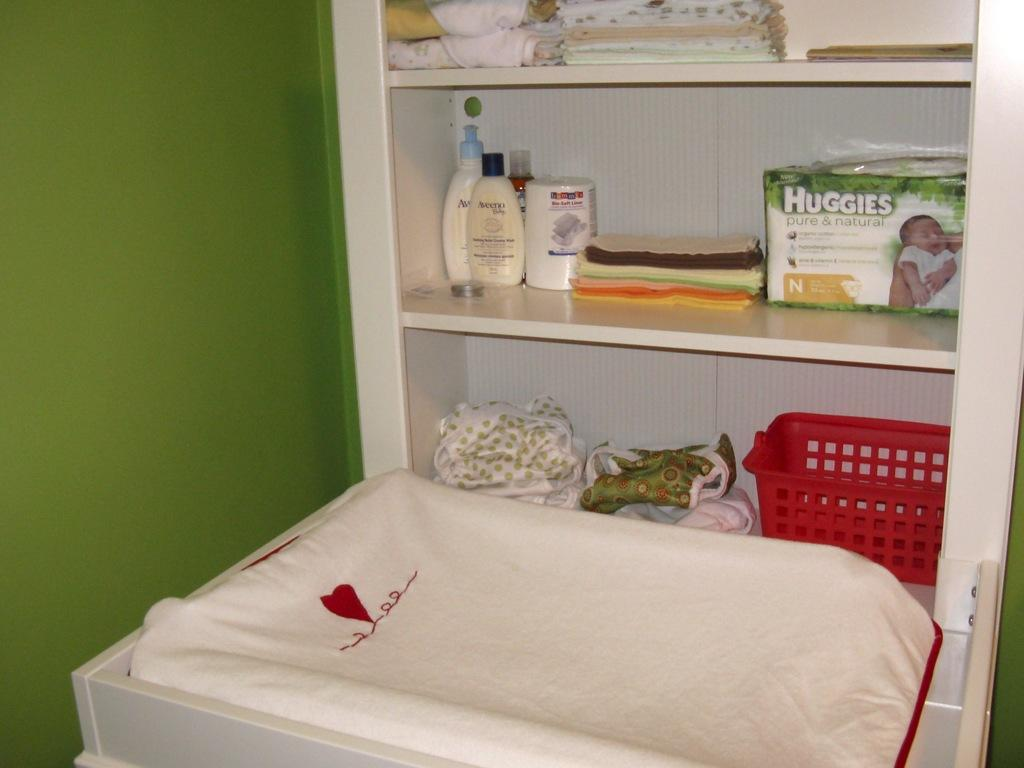<image>
Give a short and clear explanation of the subsequent image. A white changing table cabinet with a white changing mat featuring a single red heart design and baby items on the shelves including Huggies diapers 